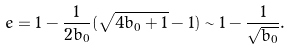<formula> <loc_0><loc_0><loc_500><loc_500>e = 1 - \frac { 1 } { 2 b _ { 0 } } ( \sqrt { 4 b _ { 0 } + 1 } - 1 ) \sim 1 - \frac { 1 } { \sqrt { b _ { 0 } } } .</formula> 